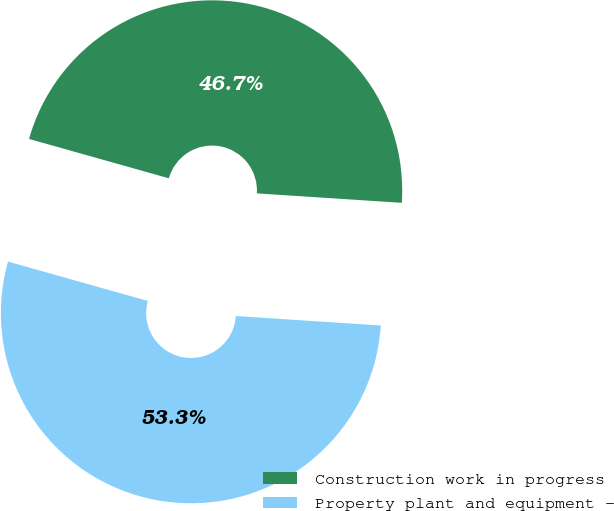<chart> <loc_0><loc_0><loc_500><loc_500><pie_chart><fcel>Construction work in progress<fcel>Property plant and equipment -<nl><fcel>46.67%<fcel>53.33%<nl></chart> 